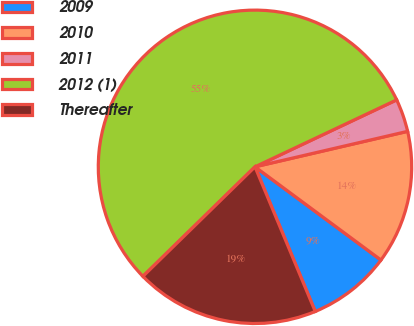Convert chart to OTSL. <chart><loc_0><loc_0><loc_500><loc_500><pie_chart><fcel>2009<fcel>2010<fcel>2011<fcel>2012 (1)<fcel>Thereafter<nl><fcel>8.58%<fcel>13.77%<fcel>3.39%<fcel>55.29%<fcel>18.96%<nl></chart> 